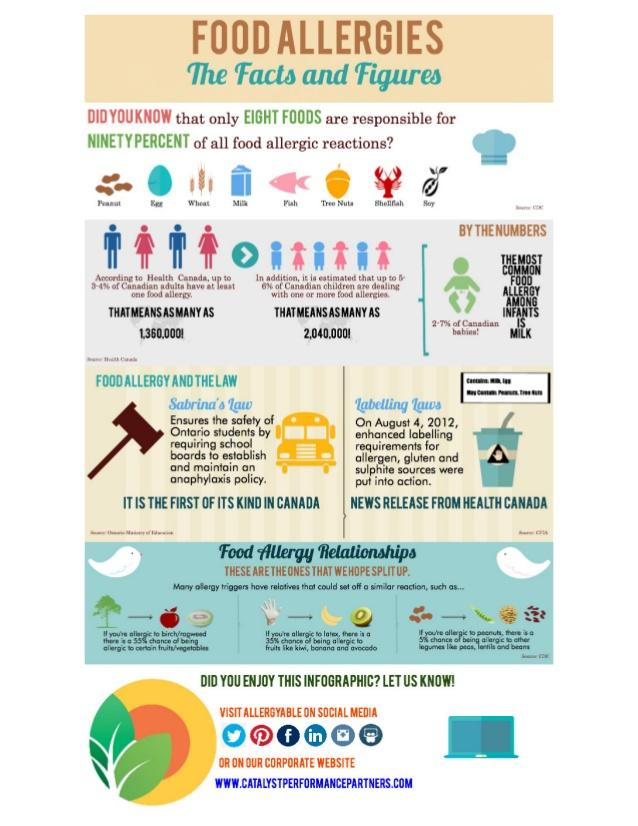Mention a couple of crucial points in this snapshot. The infographic contains 6 social media network icons. 